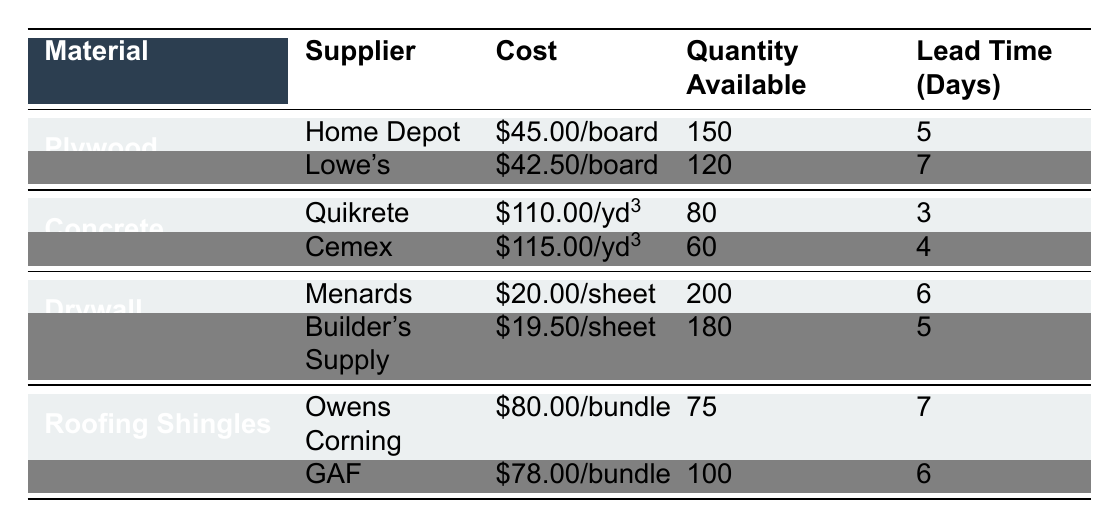What is the cost per board of plywood from Lowe's? According to the table, Lowe's offers plywood at a cost of $42.50 per board.
Answer: $42.50 What is the total quantity of concrete available from both suppliers? By looking at the table, the quantity available from Quikrete is 80 and from Cemex is 60. So, the total quantity is 80 + 60 = 140.
Answer: 140 Which supplier has the lowest lead time for roofing shingles? From the table, Owens Corning has a lead time of 7 days, while GAF has a lead time of 6 days. Therefore, GAF has the lowest lead time.
Answer: GAF Is the cost per sheet of drywall from Builder's Supply less than $20? The cost per sheet from Builder's Supply is $19.50, which is indeed less than $20.
Answer: Yes What is the average cost per board for plywood from both suppliers? The cost per board from Home Depot is $45.00 and from Lowe's is $42.50. To find the average, we sum these costs: $45.00 + $42.50 = $87.50 and divide by 2, yielding an average of $43.75.
Answer: $43.75 How much more quantity of drywall is available from Menards than Builder's Supply? Menards has 200 sheets of drywall, while Builder's Supply has 180 sheets. The difference is calculated as 200 - 180 = 20 sheets.
Answer: 20 sheets Which material has the highest cost per unit? The table shows that Concrete from Quikrete costs $110.00 per cubic yard, and this is the highest cost compared to other materials listed.
Answer: Concrete from Quikrete How many more roofing shingles are available from GAF compared to Owens Corning? GAF has 100 bundles of roofing shingles available, while Owens Corning has 75 bundles. The difference in availability is calculated: 100 - 75 = 25 bundles.
Answer: 25 bundles Which supplier offers a greater number of plywood boards, Home Depot or Lowe's? According to the table, Home Depot has 150 boards available, while Lowe's has 120 boards. Thus, Home Depot offers more plywood boards.
Answer: Home Depot 